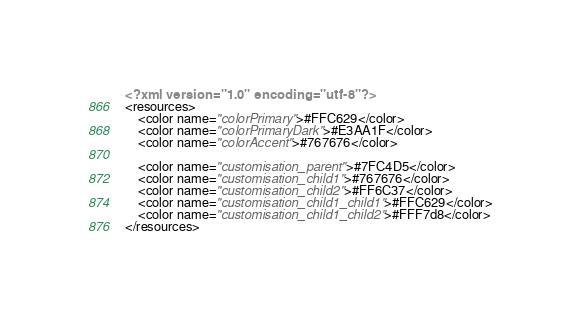<code> <loc_0><loc_0><loc_500><loc_500><_XML_><?xml version="1.0" encoding="utf-8"?>
<resources>
    <color name="colorPrimary">#FFC629</color>
    <color name="colorPrimaryDark">#E3AA1F</color>
    <color name="colorAccent">#767676</color>

    <color name="customisation_parent">#7FC4D5</color>
    <color name="customisation_child1">#767676</color>
    <color name="customisation_child2">#FF6C37</color>
    <color name="customisation_child1_child1">#FFC629</color>
    <color name="customisation_child1_child2">#FFF7d8</color>
</resources>
</code> 